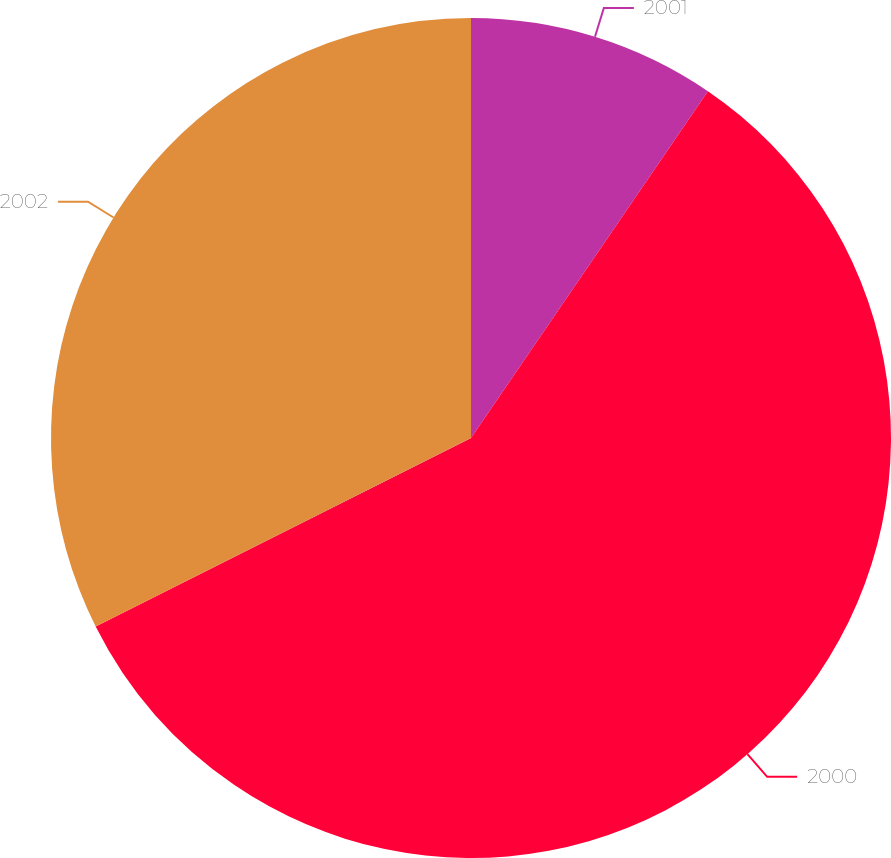Convert chart. <chart><loc_0><loc_0><loc_500><loc_500><pie_chart><fcel>2001<fcel>2000<fcel>2002<nl><fcel>9.54%<fcel>58.06%<fcel>32.41%<nl></chart> 